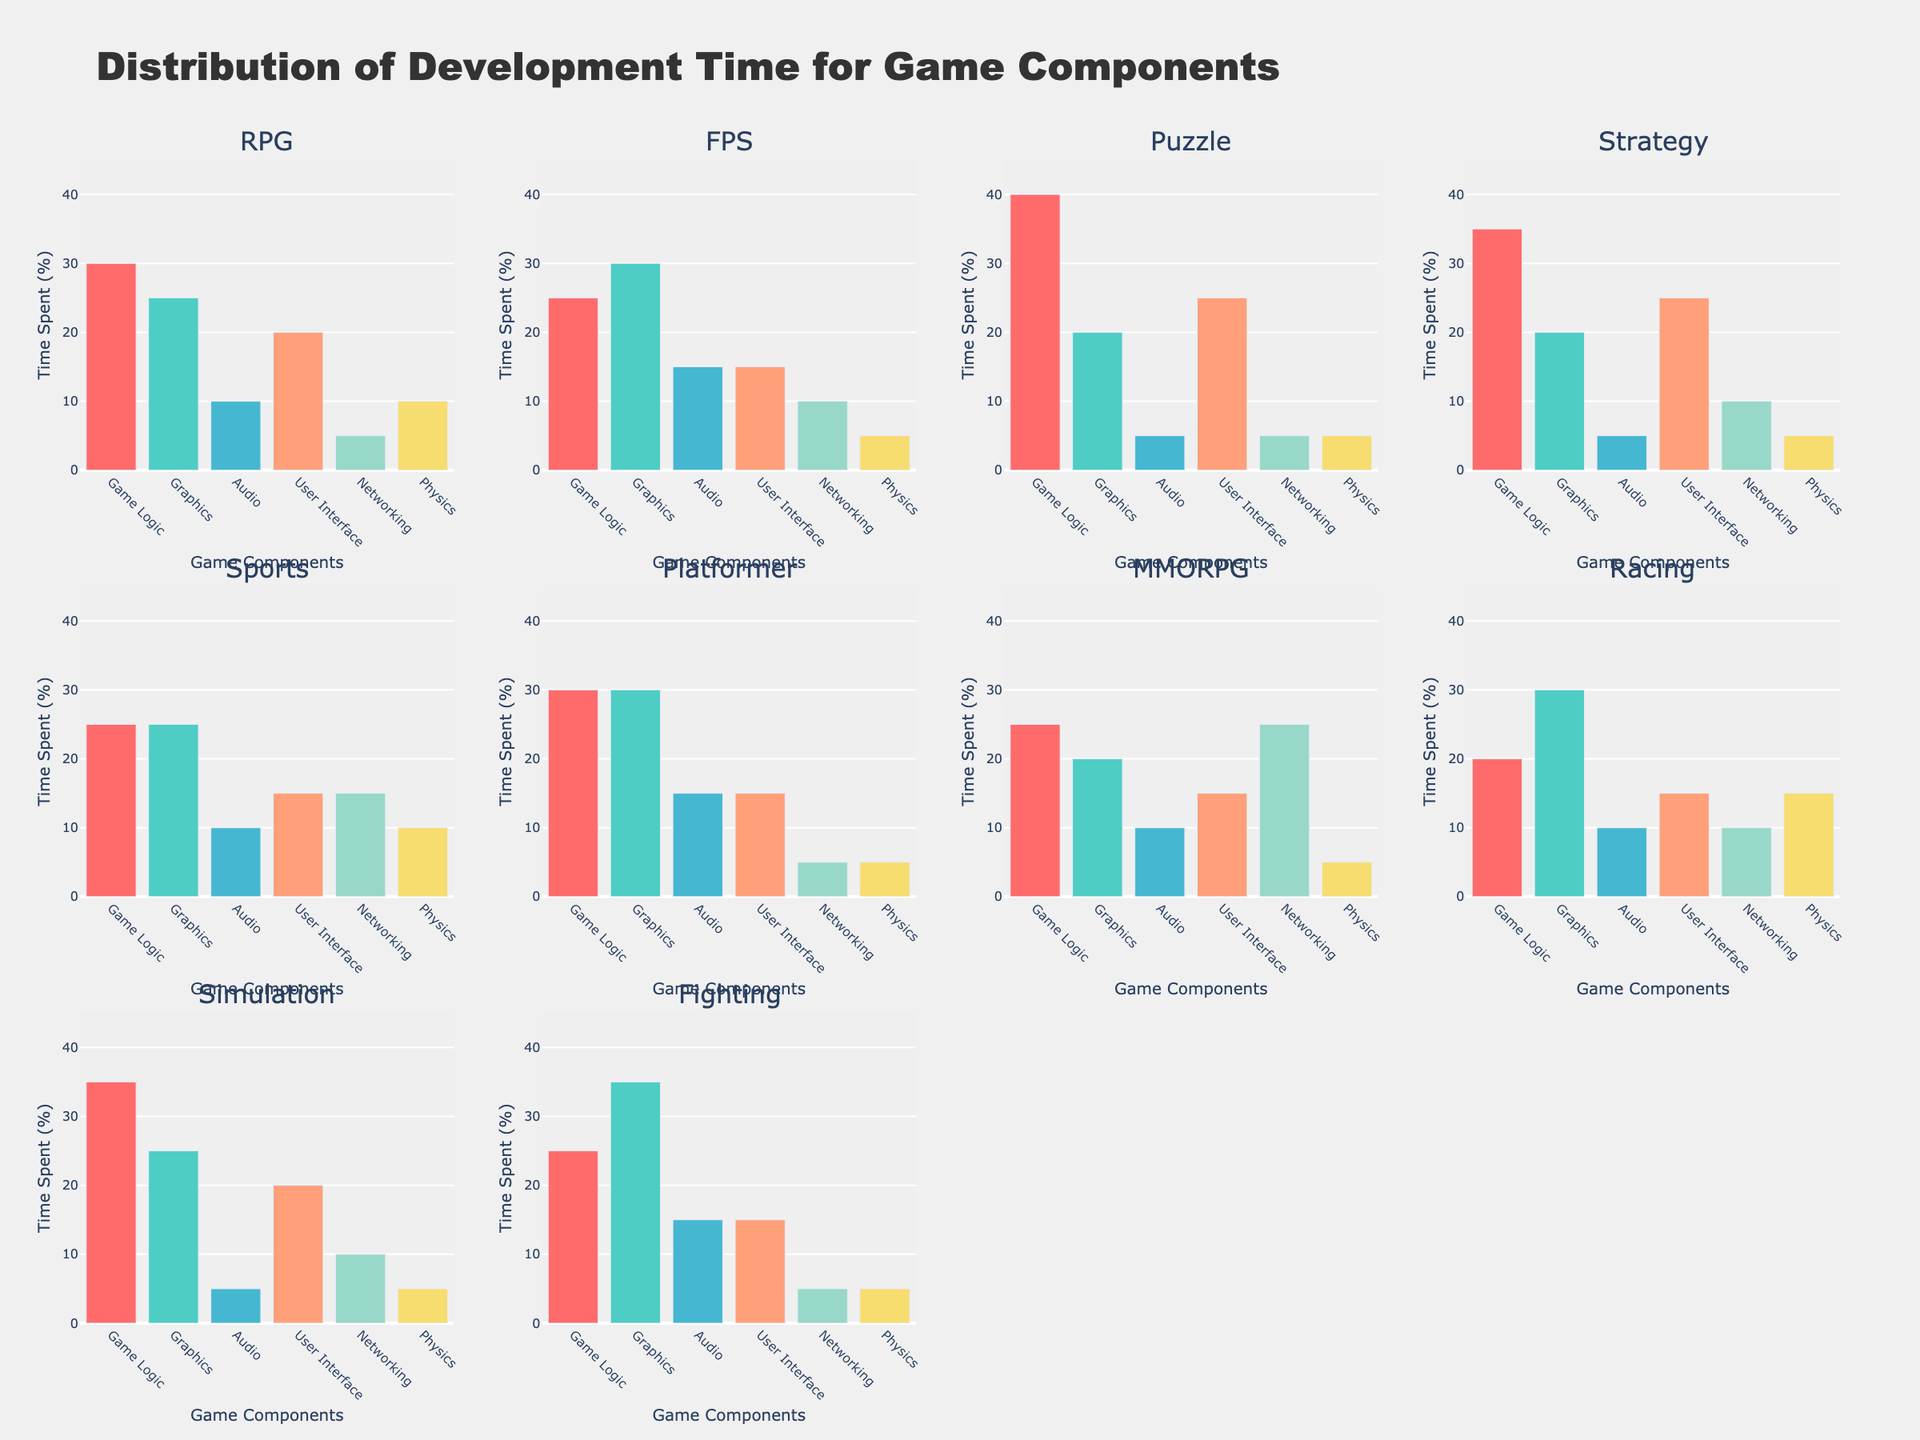What is the title of the figure? The title is typically found at the top of the figure, summarizing the content. In this case, it states "Distribution of Development Time for Game Components".
Answer: Distribution of Development Time for Game Components Which game type dedicates the most time to Networking? To determine this, look at the bars representing Networking in each subplot and identify the tallest one. MMORPG spends the most time on Networking with a value of 25%.
Answer: MMORPG How does the time spent on Graphics in Fighting games compare to FPS games? Compare the height of the Graphics bar in the Fighting subplot with the Graphics bar in the FPS subplot. The Fighting game has a 35% allocation, while the FPS game has 30%.
Answer: Fighting spends more time Which game type shows the highest percentage of time spent on Game Logic? By examining the Game Logic bars across all subplots, the highest value appears in the Puzzle game type at 40%.
Answer: Puzzle What is the total development time spent on User Interface across RPG, Strategy, and Simulation games? Add the User Interface values for RPG (20%), Strategy (25%), and Simulation (20%). The total is 20% + 25% + 20% = 65%.
Answer: 65% Between Racing and Platformer games, which spends less time on Physics? Compare the Physics bars in both subplots. Racing has 15%, whereas Platformer has 5%. Platformer spends less time.
Answer: Platformer If you average the time spent on Audio for the Platformer and Fighting game types, what is the result? Sum the Audio values for Platformer (15%) and Fighting (15%), then divide by 2. The average is (15% + 15%) / 2 = 15%.
Answer: 15% Which game type allocates equal time to both Audio and User Interface components? Look for a subplot where the Audio bar equals the User Interface bar. The FPS game allocates 15% to both components.
Answer: FPS How does the percentage of time spent on Physics in Racing games compare to that in Sports games? Compare the Physics bars in Racing and Sports subplots. Racing spends 15% and Sports 10%. Racing spends more time.
Answer: Racing spends more time What is the difference in time allocation for Game Logic between Strategy and Simulation games? Subtract the Game Logic percentage of Simulation (35%) from Strategy (35%). The difference is 0%.
Answer: 0% 